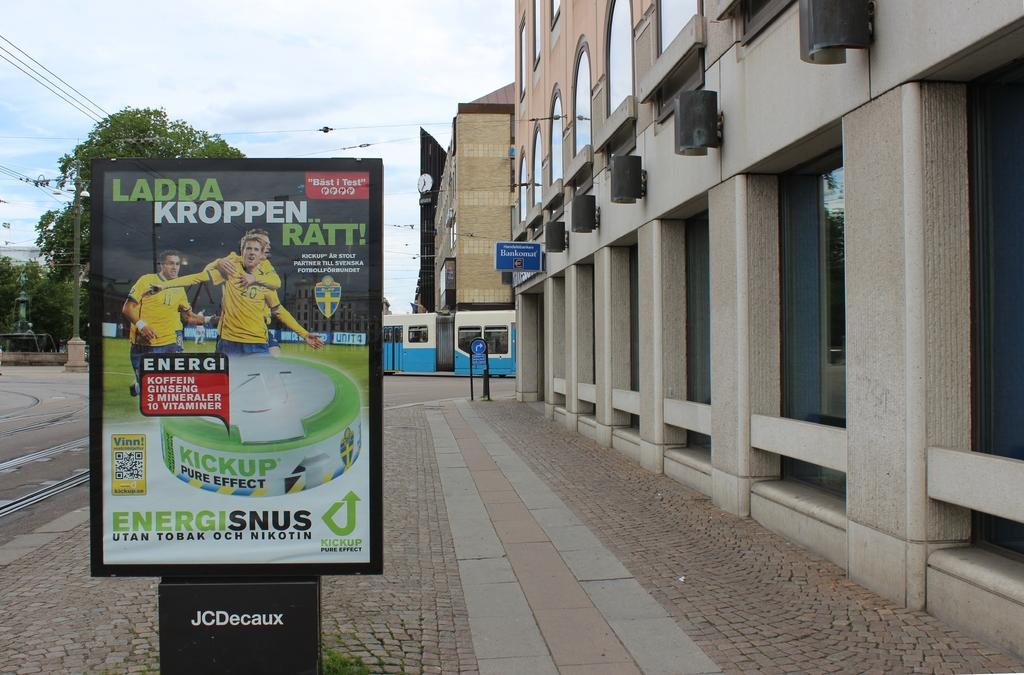What product is being advertised?
Give a very brief answer. Energisnus. 